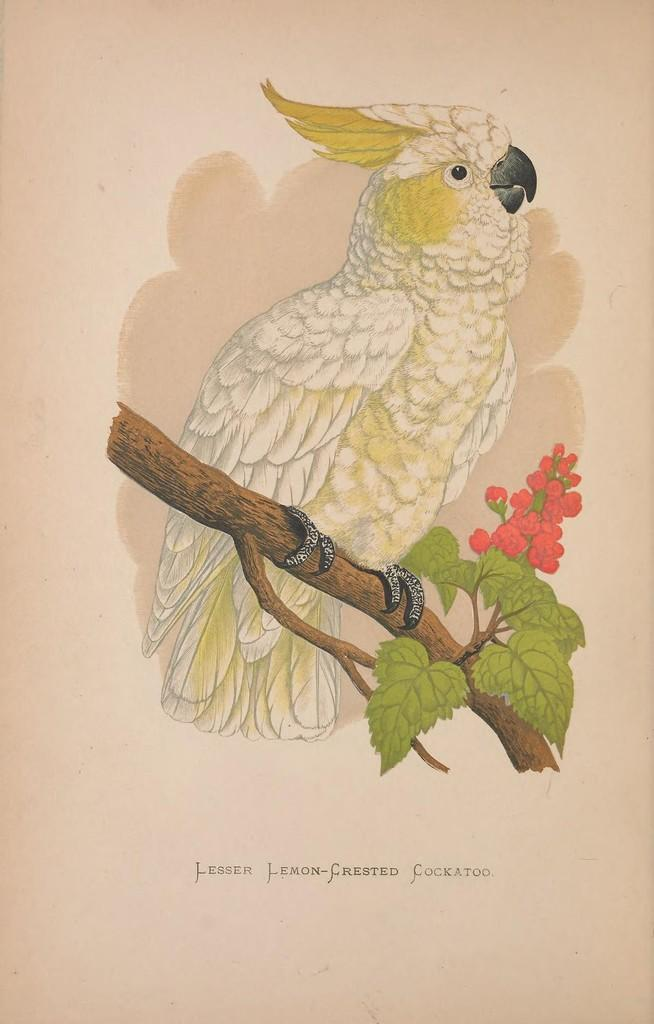What is depicted in the drawing in the picture? There is a drawing of a bird in the picture. What is the bird standing on in the drawing? The bird is standing on a branch in the drawing. What type of vegetation is present in the picture? There are leaves and flowers in the picture. What is written on the paper in the picture? There are words on the paper in the picture. Can you see a ship sailing in the background of the picture? There is no ship present in the picture; it features a drawing of a bird on a branch with leaves and flowers. Are there any worms visible in the picture? There are no worms present in the picture; it features a drawing of a bird on a branch with leaves and flowers. 